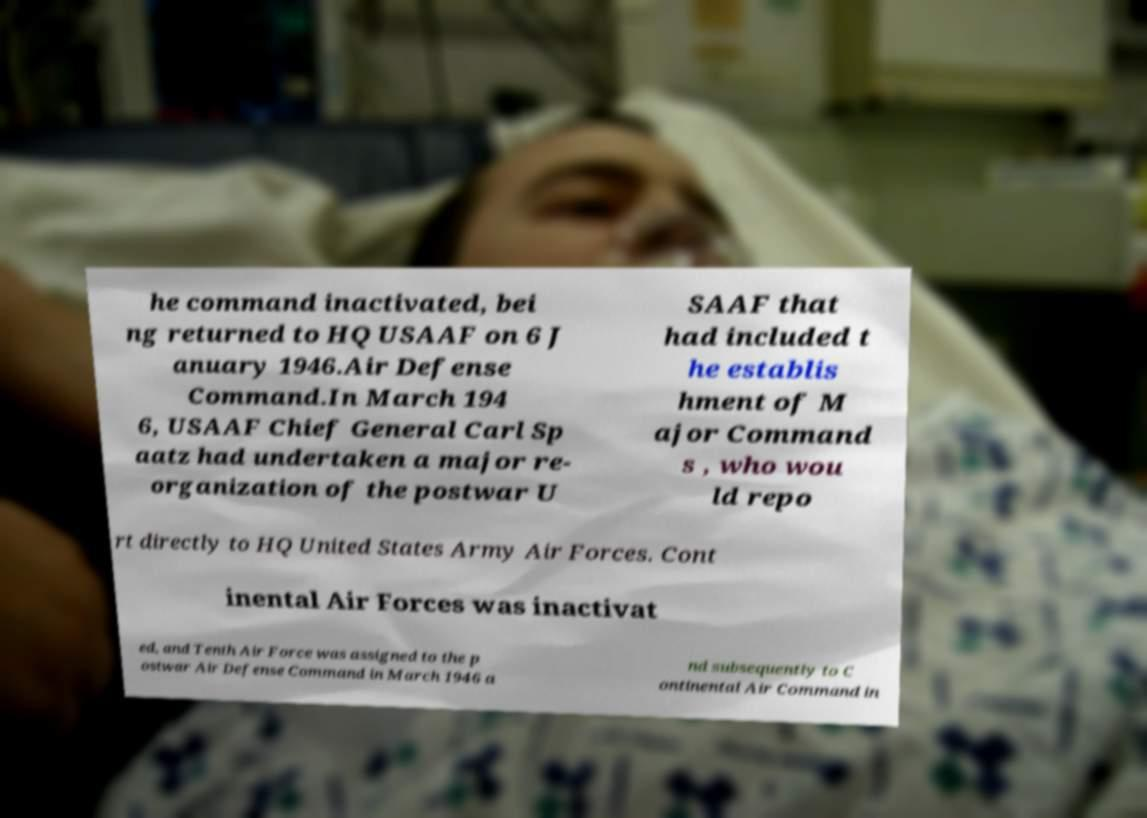What messages or text are displayed in this image? I need them in a readable, typed format. he command inactivated, bei ng returned to HQ USAAF on 6 J anuary 1946.Air Defense Command.In March 194 6, USAAF Chief General Carl Sp aatz had undertaken a major re- organization of the postwar U SAAF that had included t he establis hment of M ajor Command s , who wou ld repo rt directly to HQ United States Army Air Forces. Cont inental Air Forces was inactivat ed, and Tenth Air Force was assigned to the p ostwar Air Defense Command in March 1946 a nd subsequently to C ontinental Air Command in 